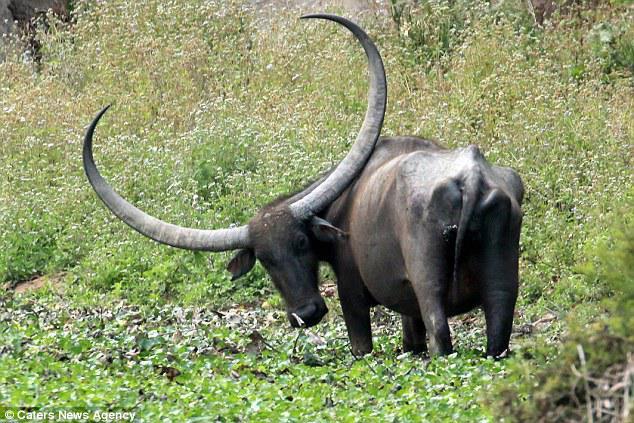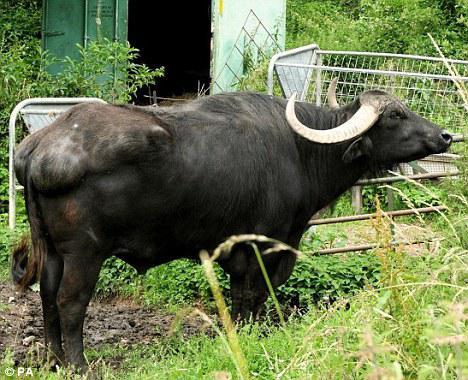The first image is the image on the left, the second image is the image on the right. Examine the images to the left and right. Is the description "The water buffalo in the right image is facing towards the right." accurate? Answer yes or no. Yes. 